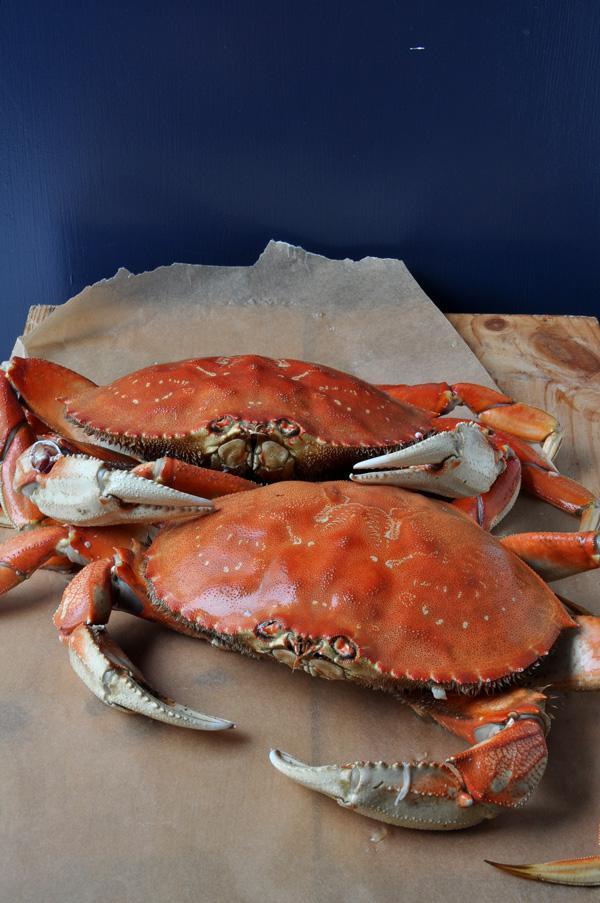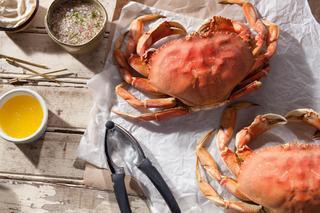The first image is the image on the left, the second image is the image on the right. For the images displayed, is the sentence "One image shows one crab on a plate next to green beans, and the other image shows at least one crab that is facing forward and not on a plate with other food items." factually correct? Answer yes or no. No. The first image is the image on the left, the second image is the image on the right. Examine the images to the left and right. Is the description "Green vegetables are served in the plate with the crab in one of the dishes." accurate? Answer yes or no. No. 